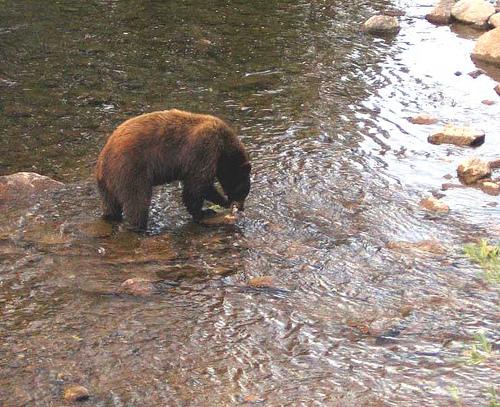Which direction is the river flowing?
Concise answer only. Downstream. What is the animal standing in?
Concise answer only. Water. How fast is the water moving in the river?
Short answer required. Slow. 